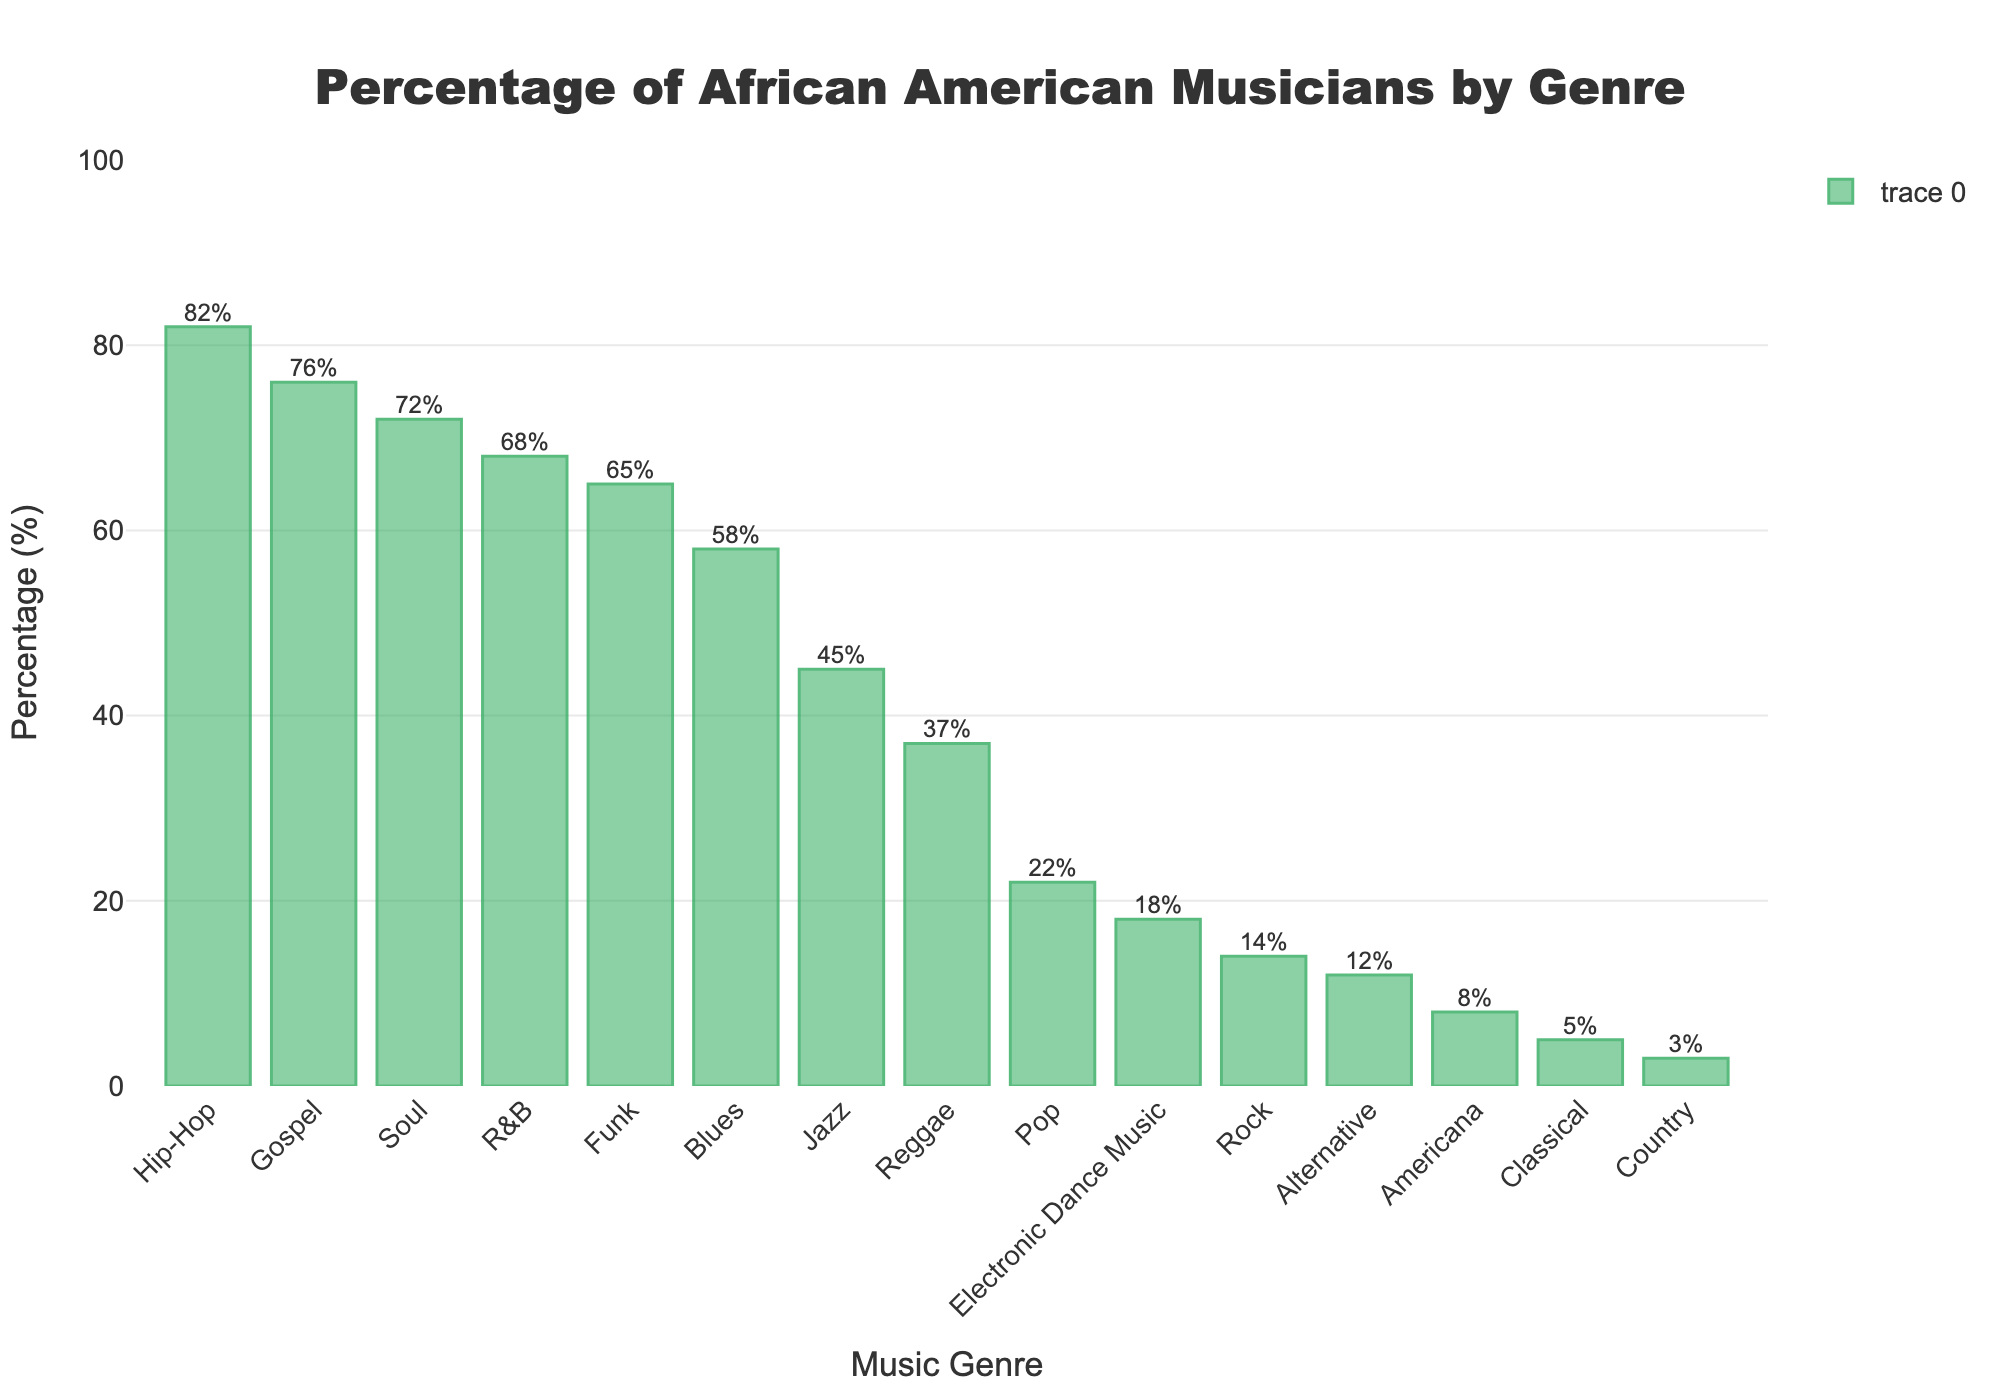Which genre has the highest percentage of African American musicians? The highest bar corresponds to Hip-Hop.
Answer: Hip-Hop What's the difference in percentage between the genres with the highest and lowest African American musicians? The highest percentage is Hip-Hop at 82%, and the lowest is Country at 3%. The difference is 82% - 3% = 79%.
Answer: 79% Which two genres are closest in percentage of African American musicians? Blues has 58% and Funk has 65%. The difference is only 7%, which is the smallest difference between any two neighboring genres.
Answer: Blues and Funk Which genre comes in third place in terms of African American musician percentages? The sorted bars show that Gospel, with 76%, is the third highest after Hip-Hop and Soul.
Answer: Gospel What is the average percentage of African American musicians for R&B, Funk, and Blues combined? The combined percentage is (68 + 65 + 58) = 191. The average is 191 / 3 = 63.67%.
Answer: 63.67% What is the sum of the percentages of African American musicians in Jazz and Reggae? The percentage for Jazz is 45%, and for Reggae, it is 37%. The sum is 45 + 37 = 82%.
Answer: 82% How many genres have more than 50% African American musicians? The genres with more than 50% are R&B, Hip-Hop, Jazz, Gospel, Soul, Funk, and Blues. This totals to 7 genres.
Answer: 7 Which genre has the least percentage of African American musicians among the top three genres? The top three genres are Hip-Hop (82%), Gospel (76%), and Soul (72%). Among these, Soul has the least percentage.
Answer: Soul How many genres have less than 20% African American musicians? The genres with less than 20% are Rock (14%), Country (3%), Classical (5%), Electronic Dance Music (18%), Alternative (12%), and Americana (8%). This totals to 6 genres.
Answer: 6 What's the percentage difference between Blues and Electronic Dance Music? The percentage for Blues is 58% and for Electronic Dance Music is 18%. The difference is 58% - 18% = 40%.
Answer: 40% 